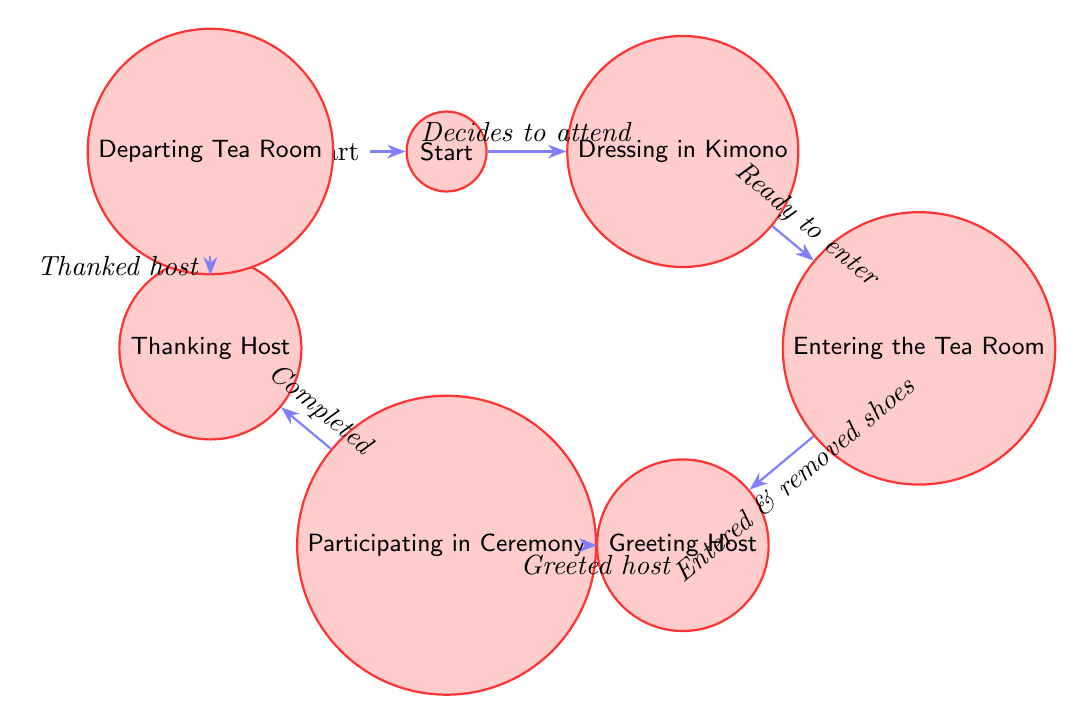What is the initial state in the diagram? The diagram starts with the state labeled "Start," which represents the student's initial interest in attending the Kimono Tea Ceremony.
Answer: Start How many states are there in total? The diagram lists a total of seven states, detailing the sequential steps from expressing interest to departing the tea room.
Answer: 7 What is the action that transitions from "Dressing in Kimono" to "Entering the Tea Room"? The transition from "Dressing in Kimono" to "Entering the Tea Room" is initiated when the student is "Dressed in kimono and ready to enter," indicating readiness to proceed.
Answer: Dressed in kimono and ready to enter Which state comes after "Greeting Host"? Following the "Greeting Host" state, the student progresses to the "Participating in Ceremony" state, marking the participation in the tea ceremony after proper greeting etiquette.
Answer: Participating in Ceremony What is the final state in the diagram? The last state in the sequence is "Departing Tea Room," which indicates the student's departure after completing the tea ceremony and thanking the host.
Answer: Departing Tea Room What two states does the transition from "Participating in Ceremony" lead to? The transition from "Participating in Ceremony" leads to "Thanking Host," which is the next step, reflecting on the completion of the participation. Therefore, it goes only to "Thanking Host."
Answer: Thanking Host How does a student enter the tea room? A student enters the tea room by following the action of "Entered tea room and removed shoes," which signifies the completion of entry and adherence to etiquette.
Answer: Entered tea room and removed shoes What is the action for leaving the tea room? The action that signifies the student leaving the tea room is "Thanked the host," demonstrating appreciation before departure.
Answer: Thanked the host 